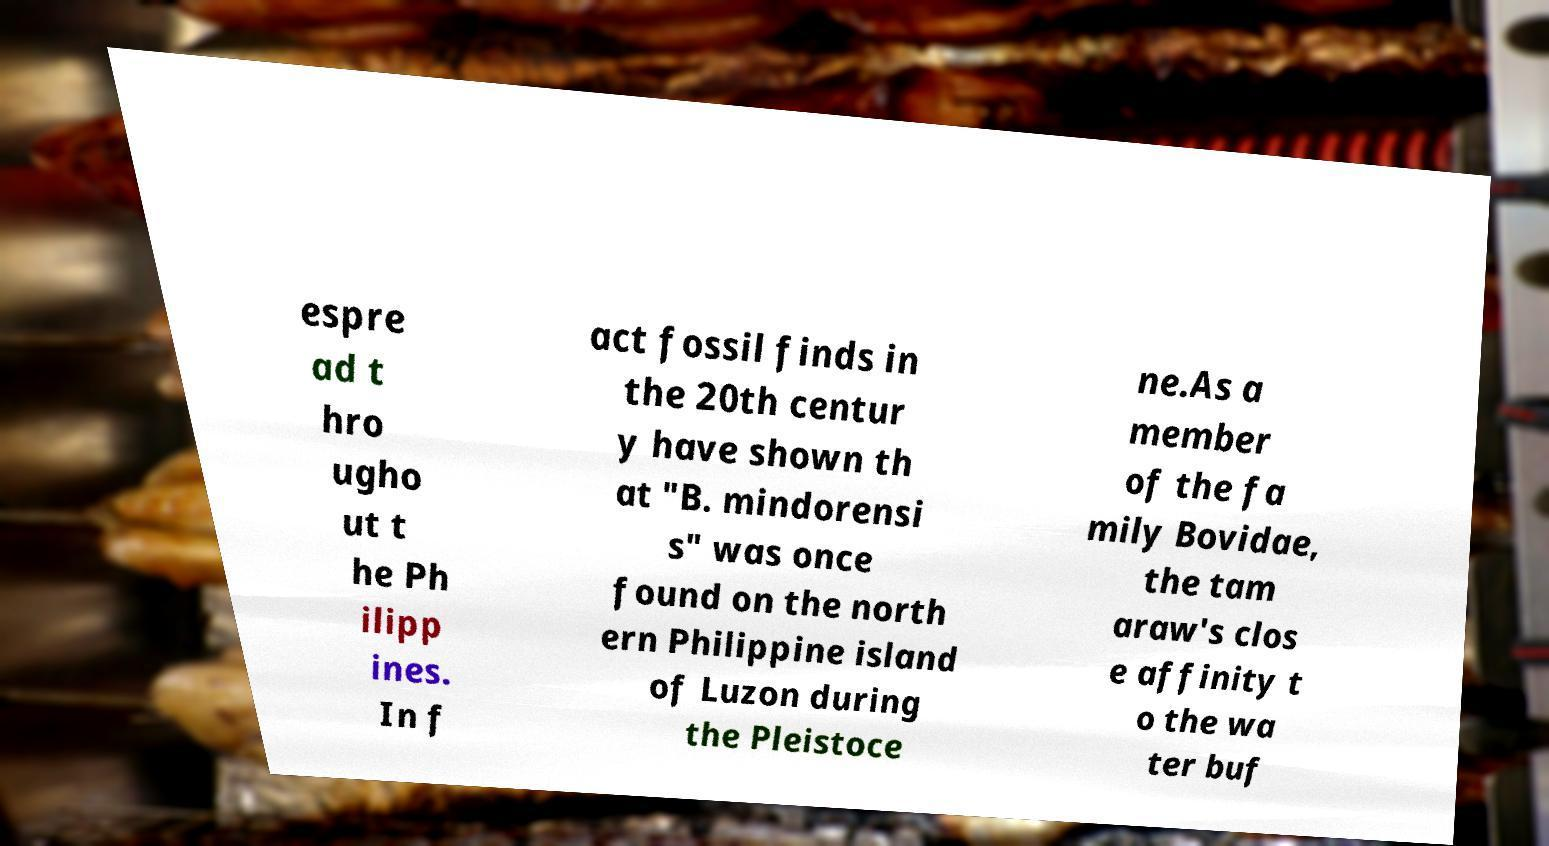What messages or text are displayed in this image? I need them in a readable, typed format. espre ad t hro ugho ut t he Ph ilipp ines. In f act fossil finds in the 20th centur y have shown th at "B. mindorensi s" was once found on the north ern Philippine island of Luzon during the Pleistoce ne.As a member of the fa mily Bovidae, the tam araw's clos e affinity t o the wa ter buf 